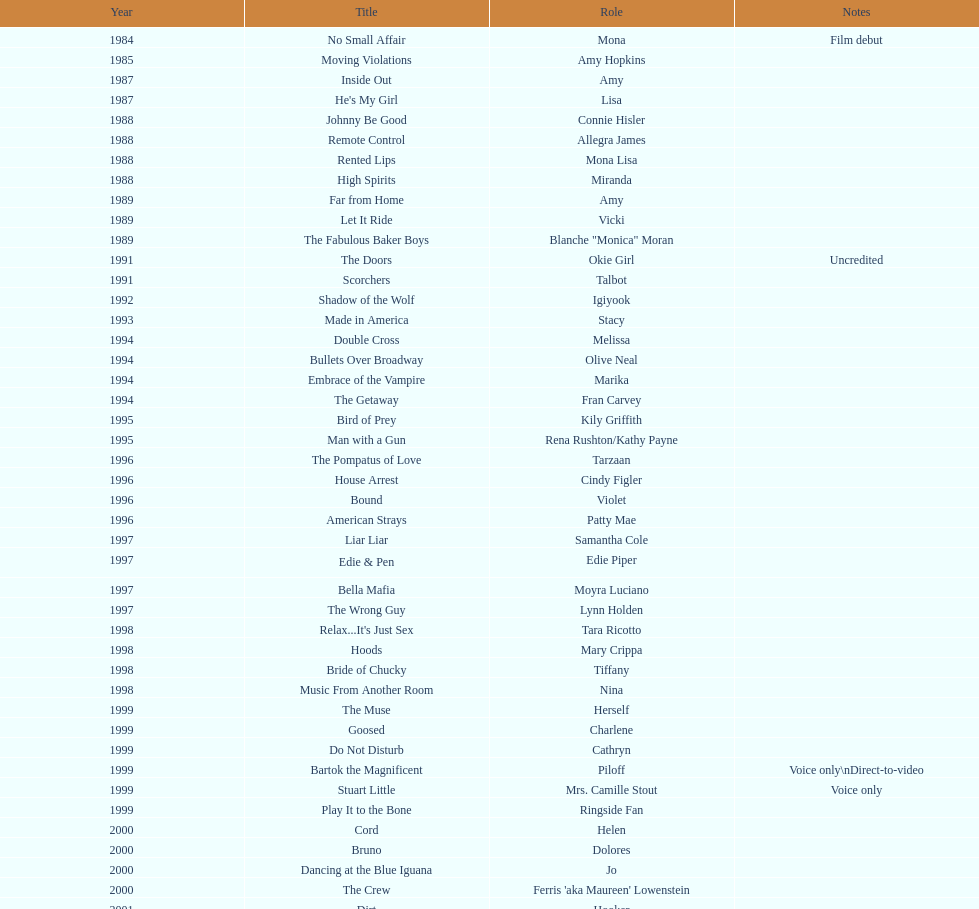How many movies does jennifer tilly play herself? 4. 